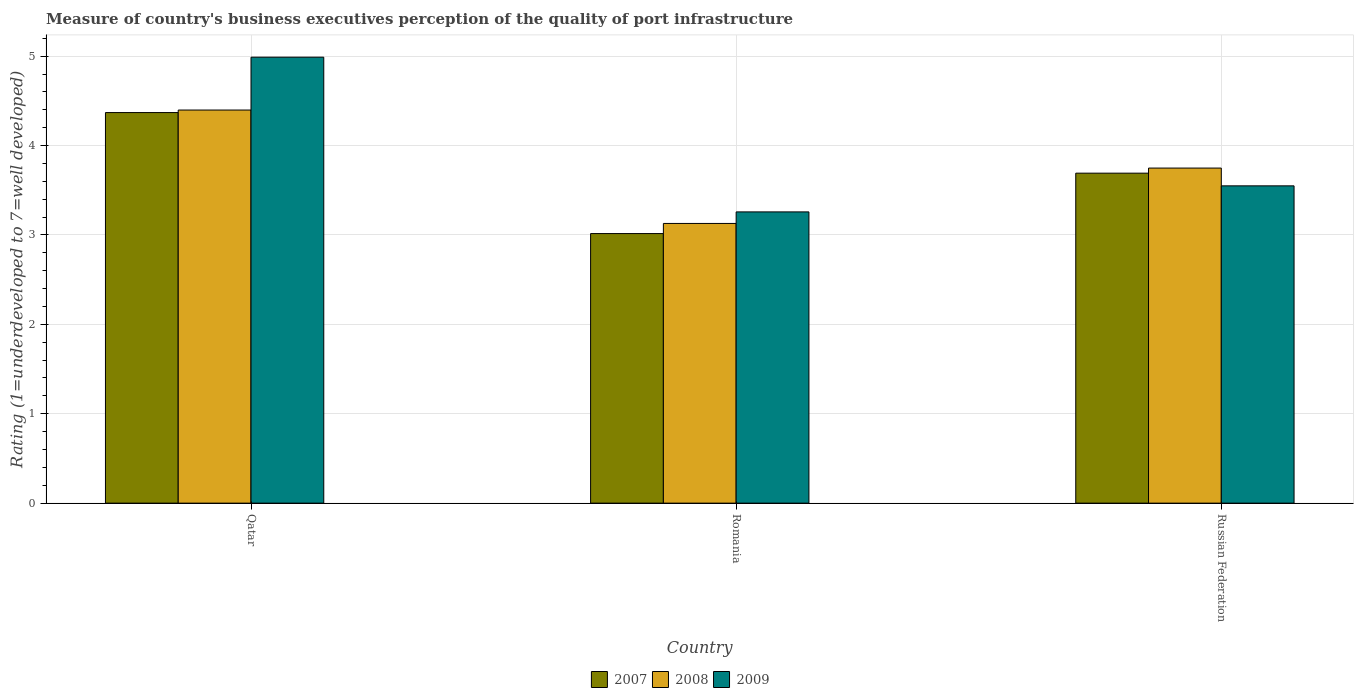How many different coloured bars are there?
Offer a terse response. 3. How many groups of bars are there?
Provide a succinct answer. 3. Are the number of bars on each tick of the X-axis equal?
Ensure brevity in your answer.  Yes. How many bars are there on the 1st tick from the left?
Provide a succinct answer. 3. What is the label of the 1st group of bars from the left?
Your answer should be compact. Qatar. In how many cases, is the number of bars for a given country not equal to the number of legend labels?
Make the answer very short. 0. What is the ratings of the quality of port infrastructure in 2007 in Russian Federation?
Make the answer very short. 3.69. Across all countries, what is the maximum ratings of the quality of port infrastructure in 2007?
Make the answer very short. 4.37. Across all countries, what is the minimum ratings of the quality of port infrastructure in 2007?
Ensure brevity in your answer.  3.02. In which country was the ratings of the quality of port infrastructure in 2007 maximum?
Provide a succinct answer. Qatar. In which country was the ratings of the quality of port infrastructure in 2007 minimum?
Ensure brevity in your answer.  Romania. What is the total ratings of the quality of port infrastructure in 2008 in the graph?
Make the answer very short. 11.27. What is the difference between the ratings of the quality of port infrastructure in 2009 in Qatar and that in Russian Federation?
Your answer should be compact. 1.44. What is the difference between the ratings of the quality of port infrastructure in 2007 in Qatar and the ratings of the quality of port infrastructure in 2009 in Romania?
Make the answer very short. 1.11. What is the average ratings of the quality of port infrastructure in 2009 per country?
Your answer should be very brief. 3.93. What is the difference between the ratings of the quality of port infrastructure of/in 2008 and ratings of the quality of port infrastructure of/in 2007 in Romania?
Offer a terse response. 0.11. In how many countries, is the ratings of the quality of port infrastructure in 2008 greater than 2.6?
Keep it short and to the point. 3. What is the ratio of the ratings of the quality of port infrastructure in 2007 in Romania to that in Russian Federation?
Your response must be concise. 0.82. Is the ratings of the quality of port infrastructure in 2007 in Qatar less than that in Russian Federation?
Offer a very short reply. No. What is the difference between the highest and the second highest ratings of the quality of port infrastructure in 2008?
Offer a terse response. -0.62. What is the difference between the highest and the lowest ratings of the quality of port infrastructure in 2009?
Offer a very short reply. 1.73. In how many countries, is the ratings of the quality of port infrastructure in 2007 greater than the average ratings of the quality of port infrastructure in 2007 taken over all countries?
Give a very brief answer. 1. What does the 3rd bar from the left in Russian Federation represents?
Your answer should be very brief. 2009. Are all the bars in the graph horizontal?
Your response must be concise. No. Are the values on the major ticks of Y-axis written in scientific E-notation?
Provide a succinct answer. No. Does the graph contain grids?
Provide a succinct answer. Yes. What is the title of the graph?
Offer a very short reply. Measure of country's business executives perception of the quality of port infrastructure. Does "1992" appear as one of the legend labels in the graph?
Make the answer very short. No. What is the label or title of the Y-axis?
Make the answer very short. Rating (1=underdeveloped to 7=well developed). What is the Rating (1=underdeveloped to 7=well developed) of 2007 in Qatar?
Make the answer very short. 4.37. What is the Rating (1=underdeveloped to 7=well developed) in 2008 in Qatar?
Offer a terse response. 4.4. What is the Rating (1=underdeveloped to 7=well developed) in 2009 in Qatar?
Ensure brevity in your answer.  4.99. What is the Rating (1=underdeveloped to 7=well developed) in 2007 in Romania?
Ensure brevity in your answer.  3.02. What is the Rating (1=underdeveloped to 7=well developed) in 2008 in Romania?
Provide a succinct answer. 3.13. What is the Rating (1=underdeveloped to 7=well developed) in 2009 in Romania?
Provide a short and direct response. 3.26. What is the Rating (1=underdeveloped to 7=well developed) of 2007 in Russian Federation?
Your answer should be very brief. 3.69. What is the Rating (1=underdeveloped to 7=well developed) in 2008 in Russian Federation?
Provide a short and direct response. 3.75. What is the Rating (1=underdeveloped to 7=well developed) of 2009 in Russian Federation?
Your response must be concise. 3.55. Across all countries, what is the maximum Rating (1=underdeveloped to 7=well developed) of 2007?
Give a very brief answer. 4.37. Across all countries, what is the maximum Rating (1=underdeveloped to 7=well developed) of 2008?
Ensure brevity in your answer.  4.4. Across all countries, what is the maximum Rating (1=underdeveloped to 7=well developed) of 2009?
Offer a very short reply. 4.99. Across all countries, what is the minimum Rating (1=underdeveloped to 7=well developed) of 2007?
Provide a succinct answer. 3.02. Across all countries, what is the minimum Rating (1=underdeveloped to 7=well developed) in 2008?
Your answer should be very brief. 3.13. Across all countries, what is the minimum Rating (1=underdeveloped to 7=well developed) of 2009?
Make the answer very short. 3.26. What is the total Rating (1=underdeveloped to 7=well developed) of 2007 in the graph?
Your answer should be very brief. 11.07. What is the total Rating (1=underdeveloped to 7=well developed) of 2008 in the graph?
Keep it short and to the point. 11.27. What is the total Rating (1=underdeveloped to 7=well developed) in 2009 in the graph?
Your answer should be compact. 11.8. What is the difference between the Rating (1=underdeveloped to 7=well developed) in 2007 in Qatar and that in Romania?
Offer a terse response. 1.35. What is the difference between the Rating (1=underdeveloped to 7=well developed) in 2008 in Qatar and that in Romania?
Your answer should be very brief. 1.27. What is the difference between the Rating (1=underdeveloped to 7=well developed) of 2009 in Qatar and that in Romania?
Your answer should be very brief. 1.73. What is the difference between the Rating (1=underdeveloped to 7=well developed) of 2007 in Qatar and that in Russian Federation?
Your response must be concise. 0.68. What is the difference between the Rating (1=underdeveloped to 7=well developed) in 2008 in Qatar and that in Russian Federation?
Provide a short and direct response. 0.65. What is the difference between the Rating (1=underdeveloped to 7=well developed) of 2009 in Qatar and that in Russian Federation?
Your response must be concise. 1.44. What is the difference between the Rating (1=underdeveloped to 7=well developed) of 2007 in Romania and that in Russian Federation?
Provide a short and direct response. -0.68. What is the difference between the Rating (1=underdeveloped to 7=well developed) of 2008 in Romania and that in Russian Federation?
Your response must be concise. -0.62. What is the difference between the Rating (1=underdeveloped to 7=well developed) in 2009 in Romania and that in Russian Federation?
Keep it short and to the point. -0.29. What is the difference between the Rating (1=underdeveloped to 7=well developed) of 2007 in Qatar and the Rating (1=underdeveloped to 7=well developed) of 2008 in Romania?
Your response must be concise. 1.24. What is the difference between the Rating (1=underdeveloped to 7=well developed) of 2007 in Qatar and the Rating (1=underdeveloped to 7=well developed) of 2009 in Romania?
Provide a short and direct response. 1.11. What is the difference between the Rating (1=underdeveloped to 7=well developed) of 2008 in Qatar and the Rating (1=underdeveloped to 7=well developed) of 2009 in Romania?
Provide a short and direct response. 1.14. What is the difference between the Rating (1=underdeveloped to 7=well developed) in 2007 in Qatar and the Rating (1=underdeveloped to 7=well developed) in 2008 in Russian Federation?
Your response must be concise. 0.62. What is the difference between the Rating (1=underdeveloped to 7=well developed) in 2007 in Qatar and the Rating (1=underdeveloped to 7=well developed) in 2009 in Russian Federation?
Offer a terse response. 0.82. What is the difference between the Rating (1=underdeveloped to 7=well developed) of 2008 in Qatar and the Rating (1=underdeveloped to 7=well developed) of 2009 in Russian Federation?
Your response must be concise. 0.85. What is the difference between the Rating (1=underdeveloped to 7=well developed) of 2007 in Romania and the Rating (1=underdeveloped to 7=well developed) of 2008 in Russian Federation?
Offer a terse response. -0.73. What is the difference between the Rating (1=underdeveloped to 7=well developed) in 2007 in Romania and the Rating (1=underdeveloped to 7=well developed) in 2009 in Russian Federation?
Make the answer very short. -0.53. What is the difference between the Rating (1=underdeveloped to 7=well developed) of 2008 in Romania and the Rating (1=underdeveloped to 7=well developed) of 2009 in Russian Federation?
Offer a very short reply. -0.42. What is the average Rating (1=underdeveloped to 7=well developed) in 2007 per country?
Provide a succinct answer. 3.69. What is the average Rating (1=underdeveloped to 7=well developed) in 2008 per country?
Your answer should be compact. 3.76. What is the average Rating (1=underdeveloped to 7=well developed) in 2009 per country?
Keep it short and to the point. 3.93. What is the difference between the Rating (1=underdeveloped to 7=well developed) in 2007 and Rating (1=underdeveloped to 7=well developed) in 2008 in Qatar?
Provide a short and direct response. -0.03. What is the difference between the Rating (1=underdeveloped to 7=well developed) in 2007 and Rating (1=underdeveloped to 7=well developed) in 2009 in Qatar?
Give a very brief answer. -0.62. What is the difference between the Rating (1=underdeveloped to 7=well developed) in 2008 and Rating (1=underdeveloped to 7=well developed) in 2009 in Qatar?
Your answer should be very brief. -0.59. What is the difference between the Rating (1=underdeveloped to 7=well developed) in 2007 and Rating (1=underdeveloped to 7=well developed) in 2008 in Romania?
Offer a very short reply. -0.11. What is the difference between the Rating (1=underdeveloped to 7=well developed) of 2007 and Rating (1=underdeveloped to 7=well developed) of 2009 in Romania?
Your answer should be compact. -0.24. What is the difference between the Rating (1=underdeveloped to 7=well developed) of 2008 and Rating (1=underdeveloped to 7=well developed) of 2009 in Romania?
Give a very brief answer. -0.13. What is the difference between the Rating (1=underdeveloped to 7=well developed) in 2007 and Rating (1=underdeveloped to 7=well developed) in 2008 in Russian Federation?
Your answer should be compact. -0.06. What is the difference between the Rating (1=underdeveloped to 7=well developed) in 2007 and Rating (1=underdeveloped to 7=well developed) in 2009 in Russian Federation?
Give a very brief answer. 0.14. What is the difference between the Rating (1=underdeveloped to 7=well developed) of 2008 and Rating (1=underdeveloped to 7=well developed) of 2009 in Russian Federation?
Your answer should be very brief. 0.2. What is the ratio of the Rating (1=underdeveloped to 7=well developed) in 2007 in Qatar to that in Romania?
Ensure brevity in your answer.  1.45. What is the ratio of the Rating (1=underdeveloped to 7=well developed) of 2008 in Qatar to that in Romania?
Give a very brief answer. 1.41. What is the ratio of the Rating (1=underdeveloped to 7=well developed) of 2009 in Qatar to that in Romania?
Your answer should be compact. 1.53. What is the ratio of the Rating (1=underdeveloped to 7=well developed) in 2007 in Qatar to that in Russian Federation?
Make the answer very short. 1.18. What is the ratio of the Rating (1=underdeveloped to 7=well developed) of 2008 in Qatar to that in Russian Federation?
Ensure brevity in your answer.  1.17. What is the ratio of the Rating (1=underdeveloped to 7=well developed) of 2009 in Qatar to that in Russian Federation?
Keep it short and to the point. 1.41. What is the ratio of the Rating (1=underdeveloped to 7=well developed) of 2007 in Romania to that in Russian Federation?
Offer a terse response. 0.82. What is the ratio of the Rating (1=underdeveloped to 7=well developed) in 2008 in Romania to that in Russian Federation?
Provide a succinct answer. 0.83. What is the ratio of the Rating (1=underdeveloped to 7=well developed) of 2009 in Romania to that in Russian Federation?
Your response must be concise. 0.92. What is the difference between the highest and the second highest Rating (1=underdeveloped to 7=well developed) in 2007?
Offer a very short reply. 0.68. What is the difference between the highest and the second highest Rating (1=underdeveloped to 7=well developed) of 2008?
Your response must be concise. 0.65. What is the difference between the highest and the second highest Rating (1=underdeveloped to 7=well developed) in 2009?
Offer a terse response. 1.44. What is the difference between the highest and the lowest Rating (1=underdeveloped to 7=well developed) in 2007?
Offer a very short reply. 1.35. What is the difference between the highest and the lowest Rating (1=underdeveloped to 7=well developed) of 2008?
Ensure brevity in your answer.  1.27. What is the difference between the highest and the lowest Rating (1=underdeveloped to 7=well developed) in 2009?
Make the answer very short. 1.73. 